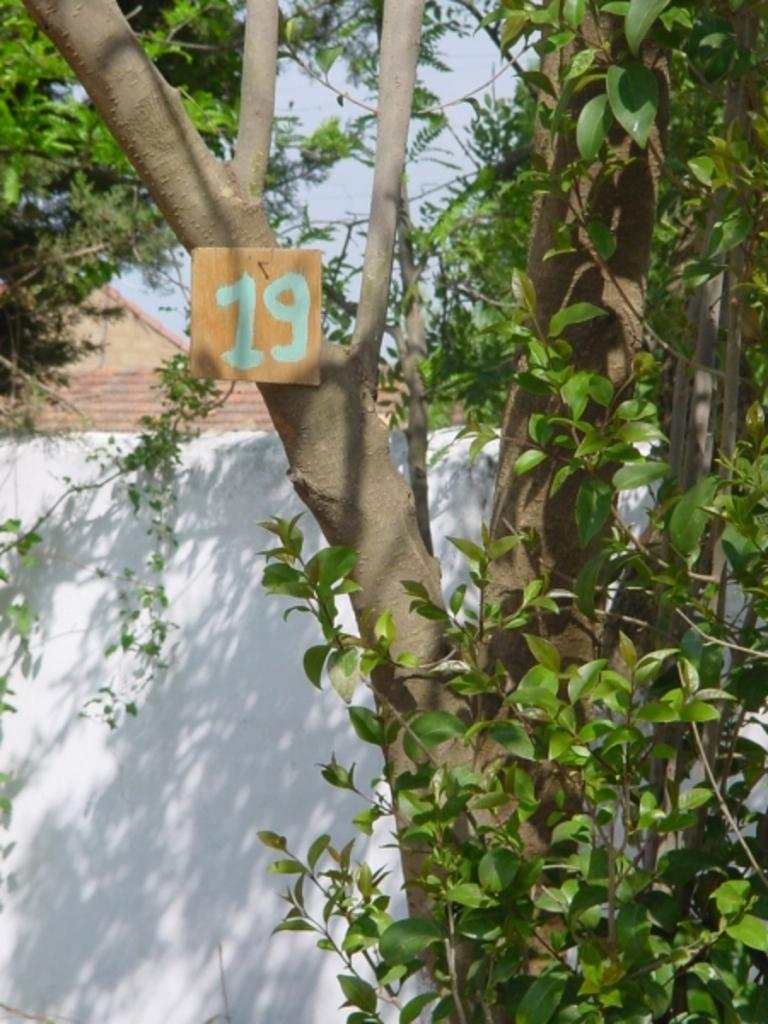What type of natural elements can be seen in the image? There are trees in the image. What type of man-made structures are present in the image? There are houses in the image. What color is the wall visible in the image? There is a white color wall in the image. Can you see a squirrel smashing into the white wall in the image? There is no squirrel present in the image, and therefore no such activity can be observed. 